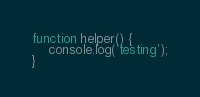Convert code to text. <code><loc_0><loc_0><loc_500><loc_500><_JavaScript_>function helper() {
    console.log('testing');
}</code> 